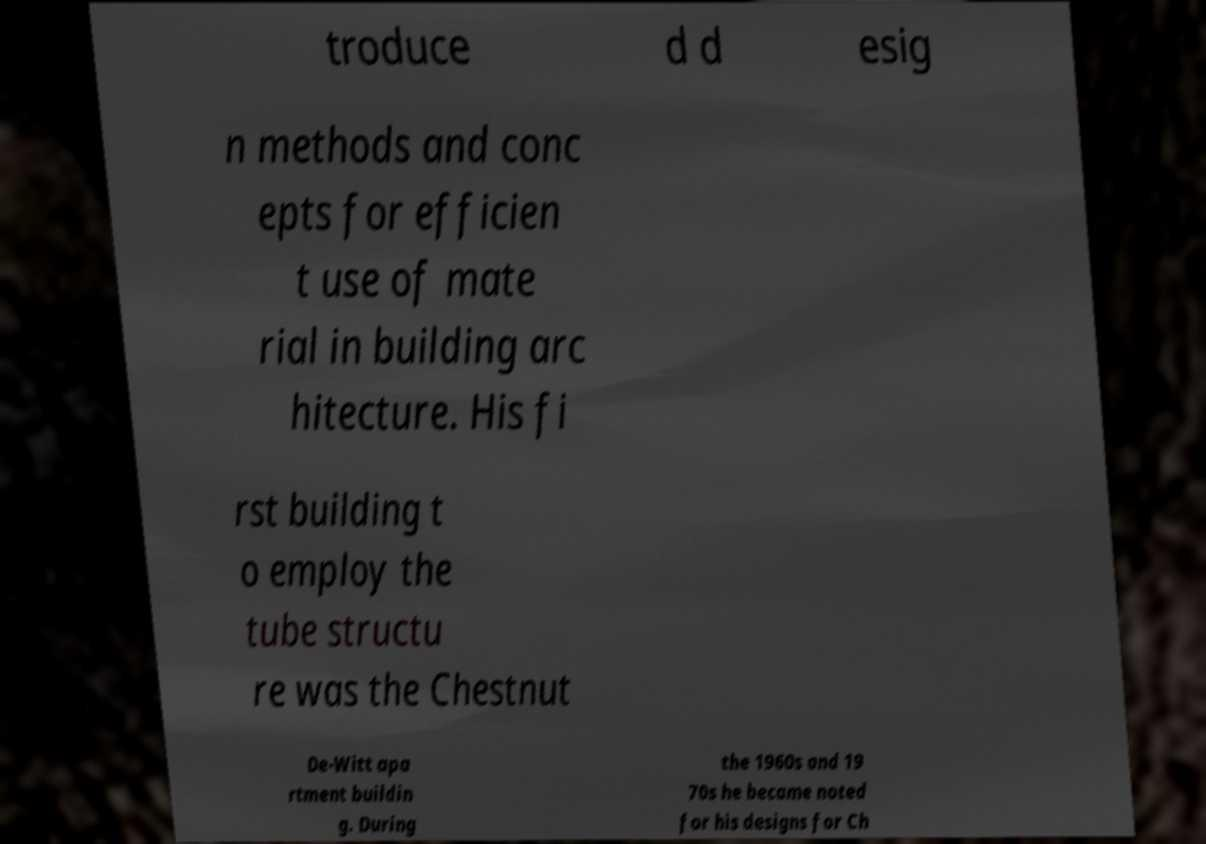Can you read and provide the text displayed in the image?This photo seems to have some interesting text. Can you extract and type it out for me? troduce d d esig n methods and conc epts for efficien t use of mate rial in building arc hitecture. His fi rst building t o employ the tube structu re was the Chestnut De-Witt apa rtment buildin g. During the 1960s and 19 70s he became noted for his designs for Ch 